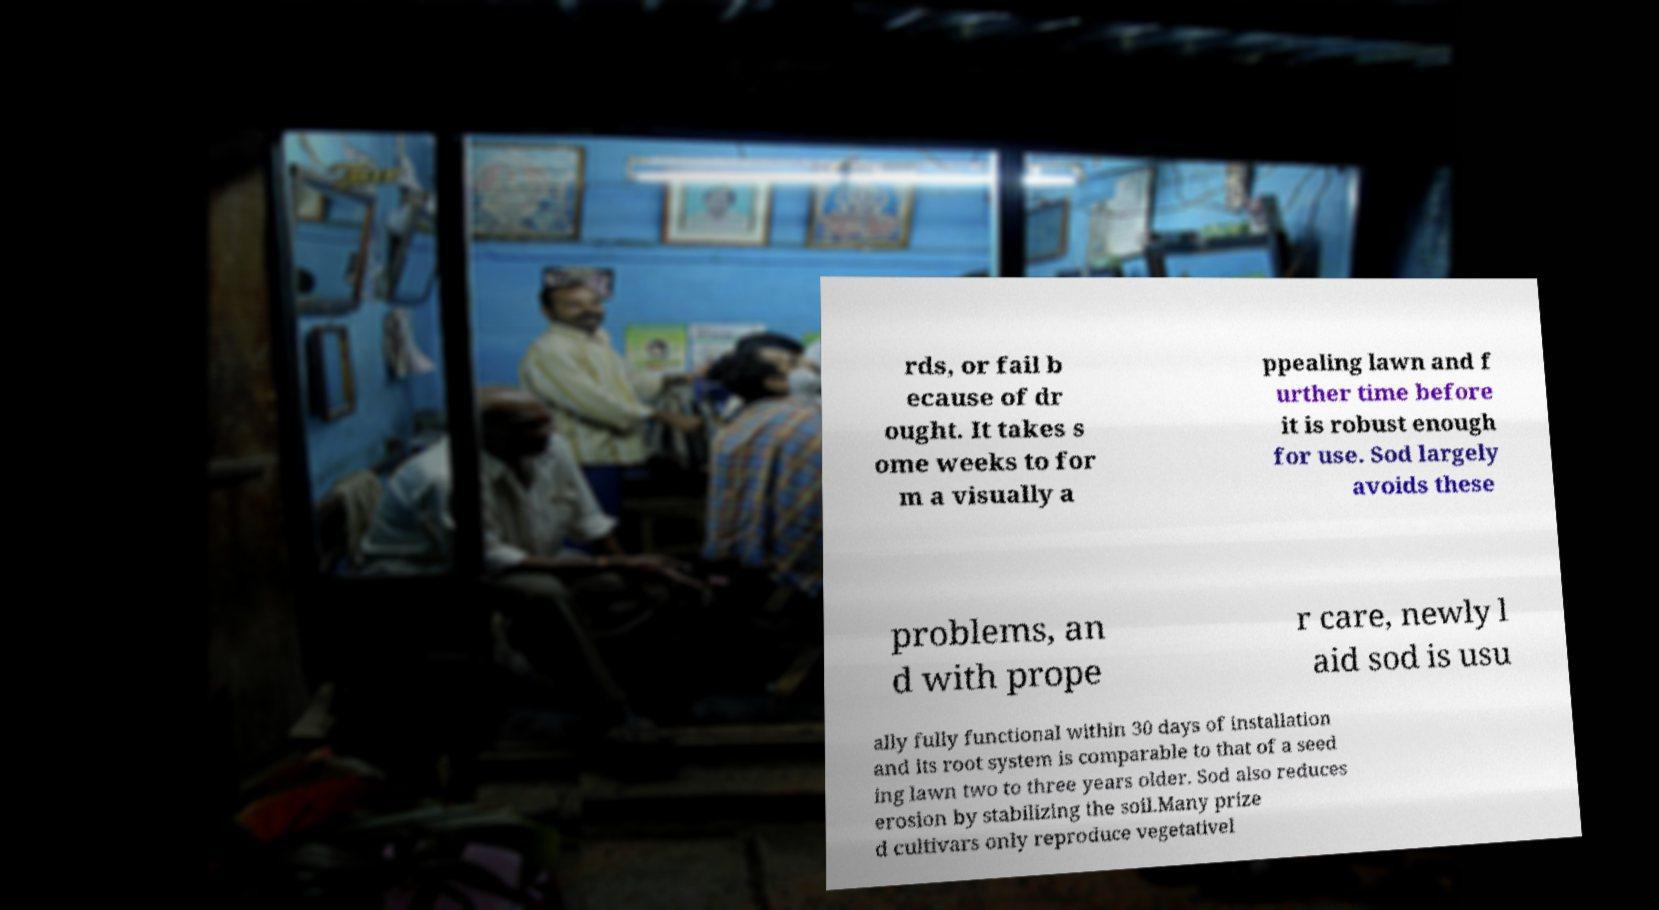Can you accurately transcribe the text from the provided image for me? rds, or fail b ecause of dr ought. It takes s ome weeks to for m a visually a ppealing lawn and f urther time before it is robust enough for use. Sod largely avoids these problems, an d with prope r care, newly l aid sod is usu ally fully functional within 30 days of installation and its root system is comparable to that of a seed ing lawn two to three years older. Sod also reduces erosion by stabilizing the soil.Many prize d cultivars only reproduce vegetativel 